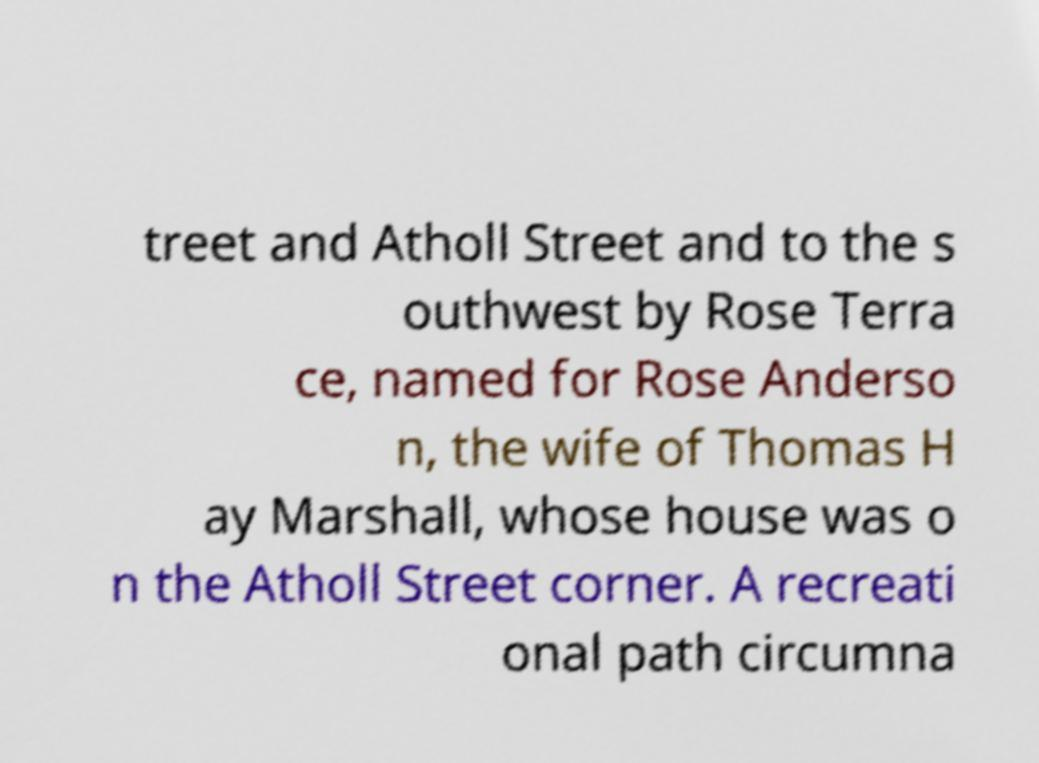Can you read and provide the text displayed in the image?This photo seems to have some interesting text. Can you extract and type it out for me? treet and Atholl Street and to the s outhwest by Rose Terra ce, named for Rose Anderso n, the wife of Thomas H ay Marshall, whose house was o n the Atholl Street corner. A recreati onal path circumna 